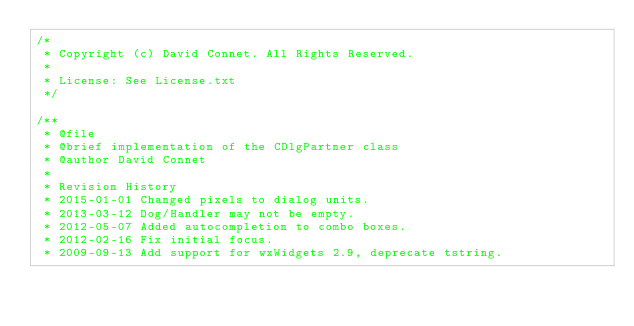Convert code to text. <code><loc_0><loc_0><loc_500><loc_500><_C++_>/*
 * Copyright (c) David Connet. All Rights Reserved.
 *
 * License: See License.txt
 */

/**
 * @file
 * @brief implementation of the CDlgPartner class
 * @author David Connet
 *
 * Revision History
 * 2015-01-01 Changed pixels to dialog units.
 * 2013-03-12 Dog/Handler may not be empty.
 * 2012-05-07 Added autocompletion to combo boxes.
 * 2012-02-16 Fix initial focus.
 * 2009-09-13 Add support for wxWidgets 2.9, deprecate tstring.</code> 